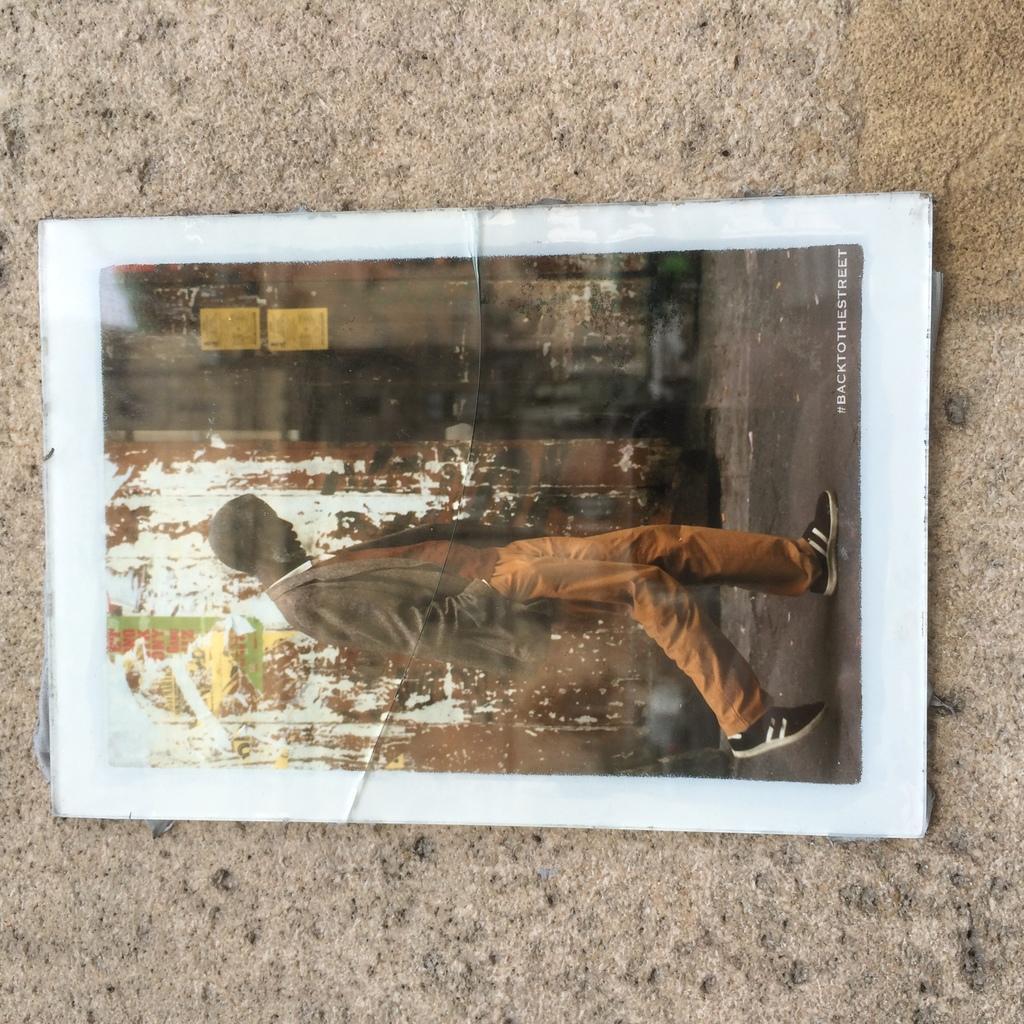Could you give a brief overview of what you see in this image? In this image I can see the photo of the person walking on the road. I can see the person is wearing the dress and cap. To the side of the person I can see some posters to the wall. 